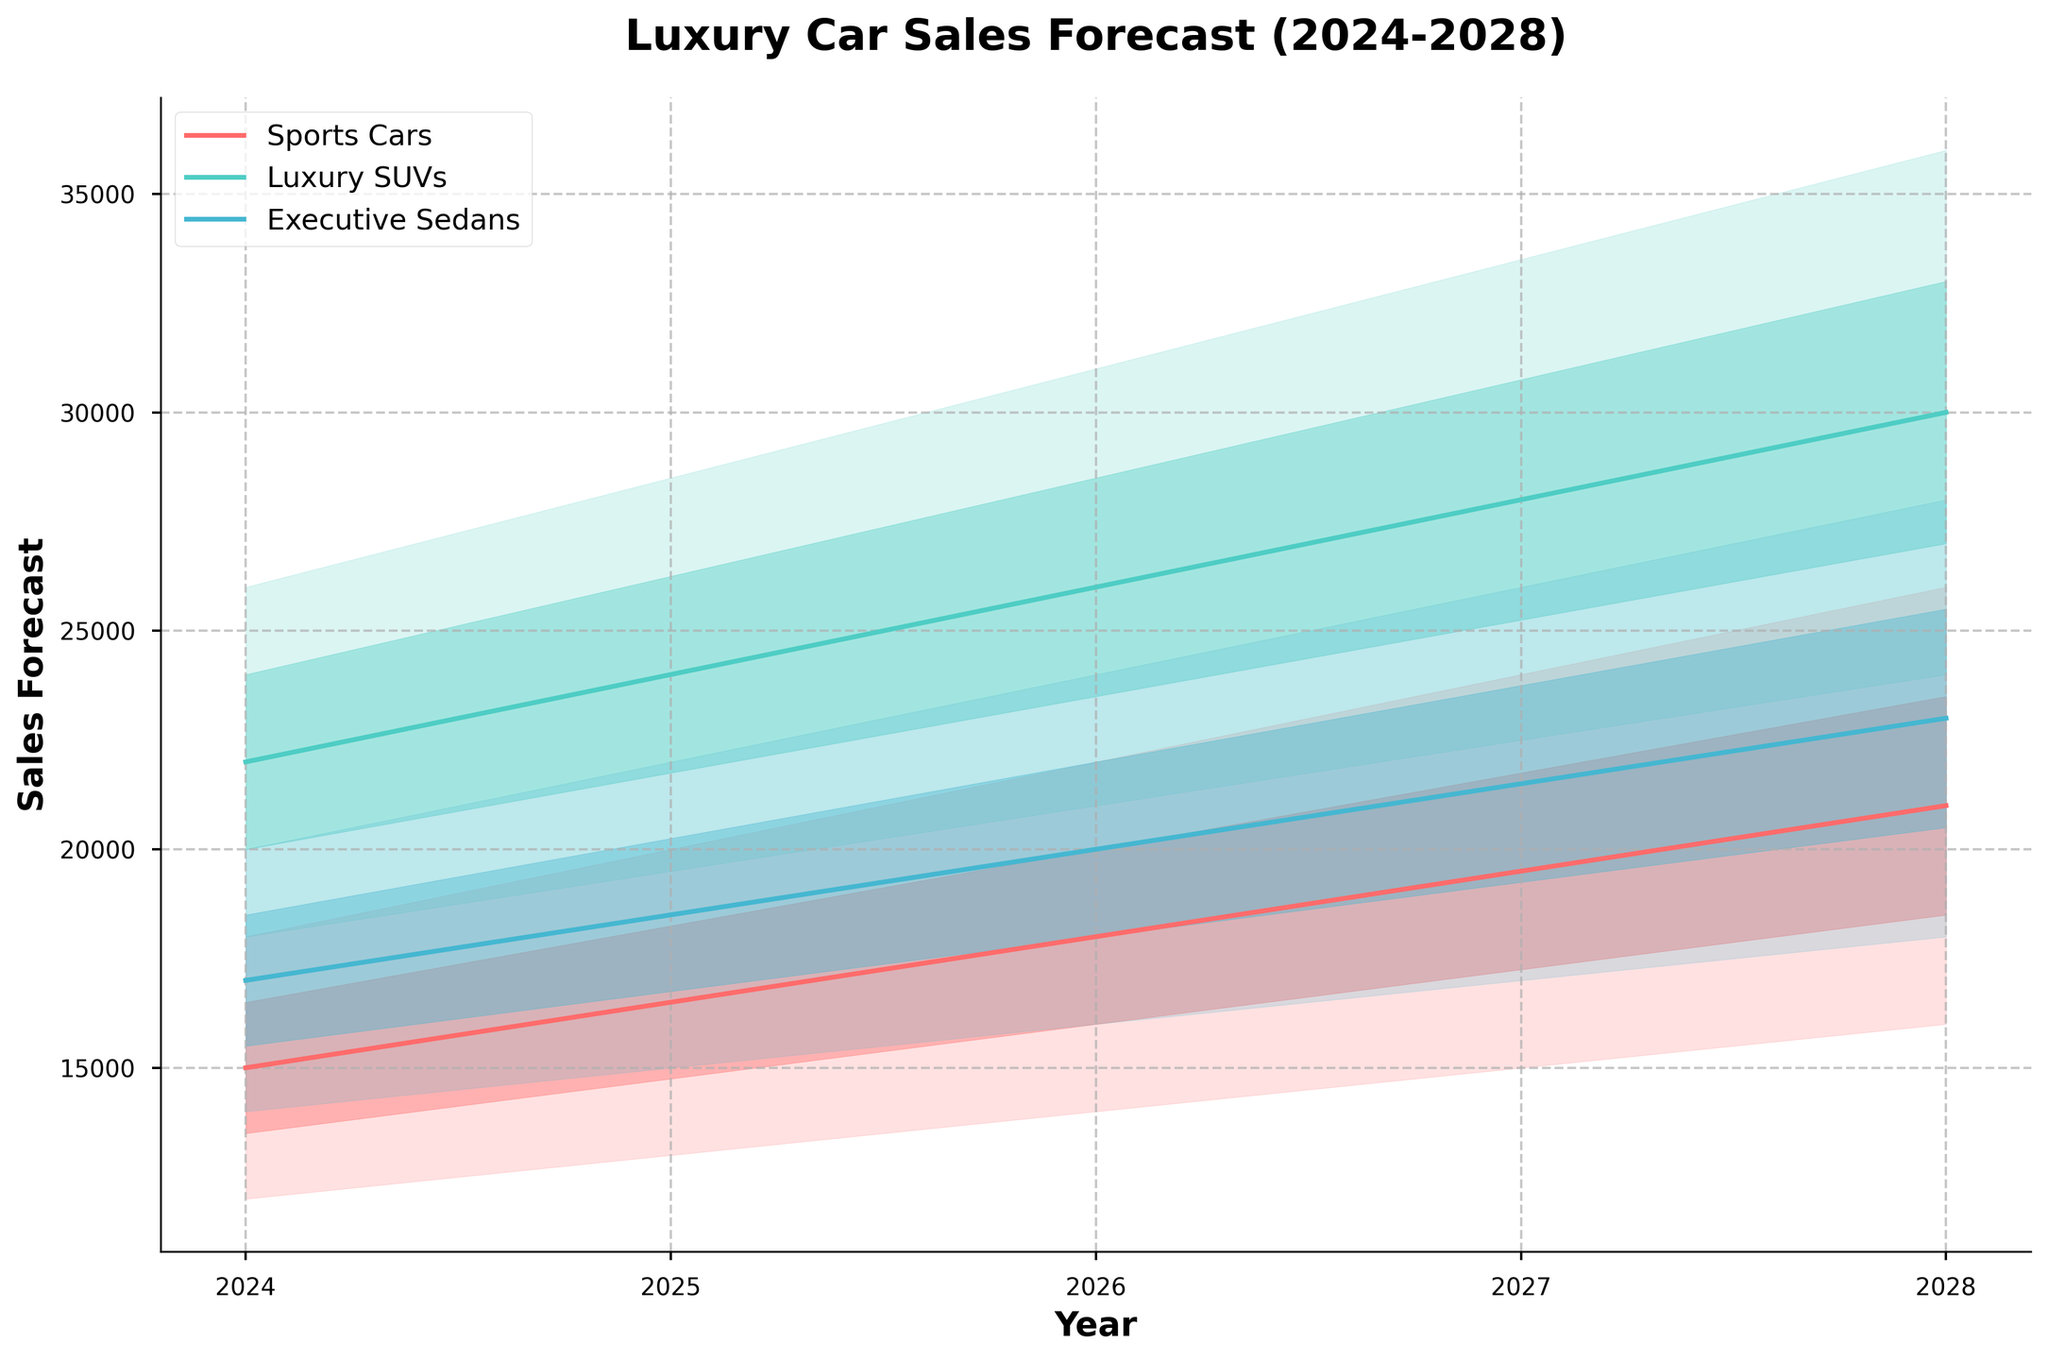What is the title of the figure? The title of the figure is located at the top of the chart and is usually the largest text in bold. It is intended to summarize the content of the chart.
Answer: Luxury Car Sales Forecast (2024-2028) Which vehicle type has the highest estimated sales value in 2026? To find the vehicle type with the highest estimated sales value in 2026, we locate the Mid Estimate column for 2026 and observe the highest value among Sports Cars, Luxury SUVs, and Executive Sedans.
Answer: Luxury SUVs What is the range of estimated sales for Executive Sedans in 2025? The range of estimated sales is found by looking at the difference between the High Estimate and the Low Estimate for Executive Sedans in 2025. The Low and High Estimates are 15000 and 22000, respectively.
Answer: 15000-22000 Is the estimated sales of Sports Cars increasing or decreasing from 2024 to 2028? To determine whether the sales are increasing or decreasing, look at the mid estimates for Sports Cars from 2024 to 2028 and check the trend. They are 15000, 16500, 18000, 19500, and 21000, respectively.
Answer: Increasing Which vehicle type shows the largest growth in mid estimate sales from 2024 to 2028? To determine this, calculate the difference between the 2028 and 2024 mid estimates for each vehicle type. Compare these differences to find the largest one. Luxury SUVs: (30000-22000)=8000; Sports Cars: (21000-15000)=6000; Executive Sedans: (23000-17000)=6000.
Answer: Luxury SUVs What is the approximate average mid estimate sales value for Luxury SUVs across all years? To find the average, sum the mid estimates for Luxury SUVs from 2024 to 2028 and divide by the number of years. They are 22000, 24000, 26000, 28000, 30000. Average = (22000+24000+26000+28000+30000)/5.
Answer: 26000 In which year do Sports Cars have the closest mid estimate sales to Executive Sedans? Compare mid estimates for Sports Cars and Executive Sedans across all years and find the year where the values are nearest. For 2024: (15000-17000)=2000; 2025: (16500-18500)=2000; 2026: (18000-20000)=2000; 2027: (19500-21500)=2000; 2028: (21000-23000)=2000. Closest differences are all equal by 2000.
Answer: All years have the same difference 